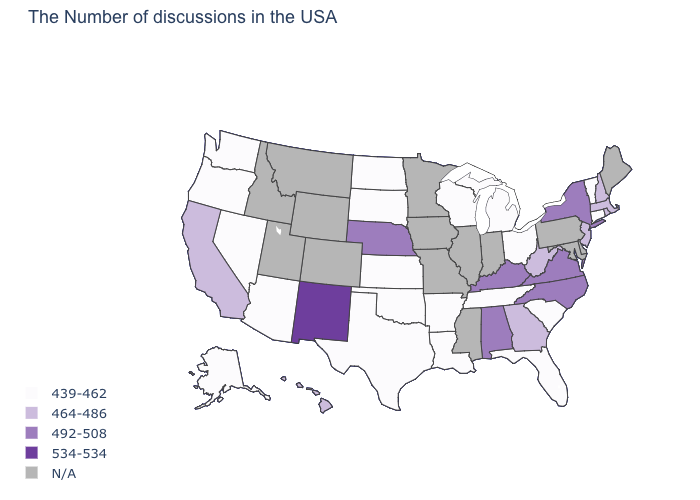What is the value of Mississippi?
Be succinct. N/A. What is the value of Texas?
Quick response, please. 439-462. What is the value of Idaho?
Write a very short answer. N/A. Name the states that have a value in the range 439-462?
Concise answer only. Vermont, Connecticut, South Carolina, Ohio, Florida, Michigan, Tennessee, Wisconsin, Louisiana, Arkansas, Kansas, Oklahoma, Texas, South Dakota, North Dakota, Arizona, Nevada, Washington, Oregon, Alaska. Does the map have missing data?
Give a very brief answer. Yes. Name the states that have a value in the range 534-534?
Short answer required. New Mexico. Does Tennessee have the highest value in the South?
Keep it brief. No. What is the lowest value in the USA?
Give a very brief answer. 439-462. How many symbols are there in the legend?
Quick response, please. 5. Which states hav the highest value in the MidWest?
Be succinct. Nebraska. Name the states that have a value in the range 492-508?
Answer briefly. New York, Virginia, North Carolina, Kentucky, Alabama, Nebraska. Name the states that have a value in the range 439-462?
Concise answer only. Vermont, Connecticut, South Carolina, Ohio, Florida, Michigan, Tennessee, Wisconsin, Louisiana, Arkansas, Kansas, Oklahoma, Texas, South Dakota, North Dakota, Arizona, Nevada, Washington, Oregon, Alaska. Name the states that have a value in the range 492-508?
Quick response, please. New York, Virginia, North Carolina, Kentucky, Alabama, Nebraska. What is the highest value in the South ?
Give a very brief answer. 492-508. 